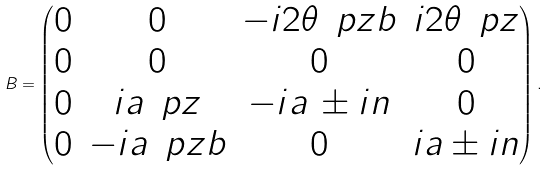<formula> <loc_0><loc_0><loc_500><loc_500>B = \begin{pmatrix} 0 & 0 & - i 2 \theta \, \ p z b & i 2 \theta \, \ p z \\ 0 & 0 & 0 & 0 \\ 0 & i a \, \ p z & - i a \, \pm i n & 0 \\ 0 & - i a \, \ p z b & 0 & i a \pm i n \end{pmatrix} .</formula> 